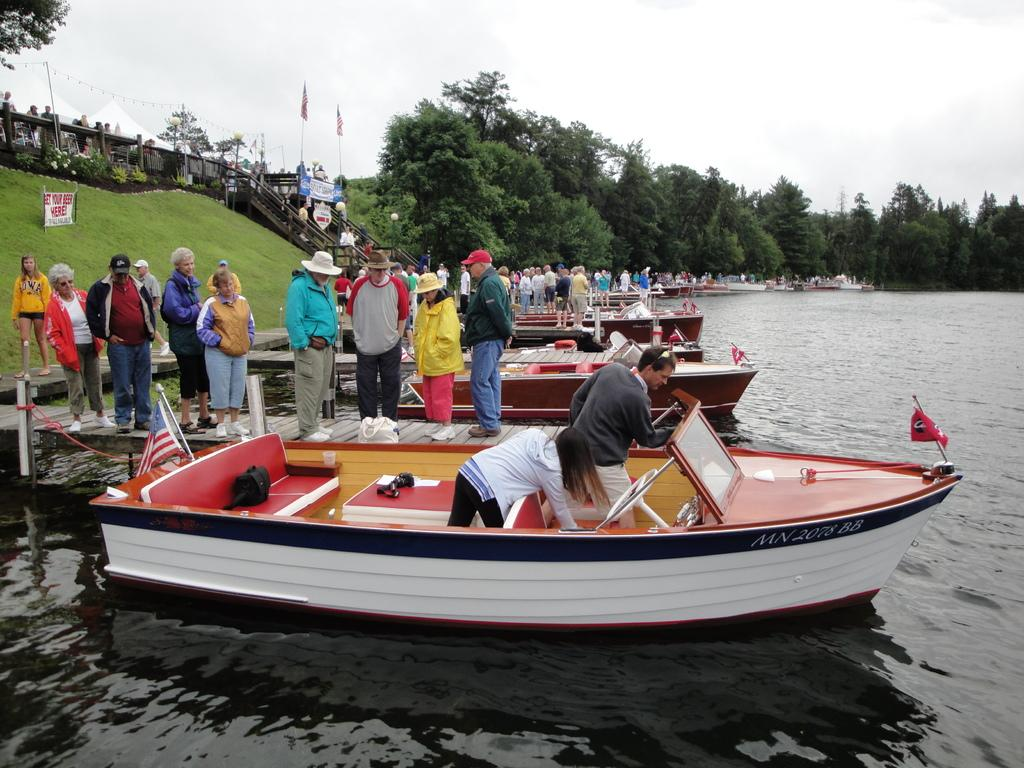Provide a one-sentence caption for the provided image. On the hill above the water is a sign that says GET YOUR BEER HERE!. 